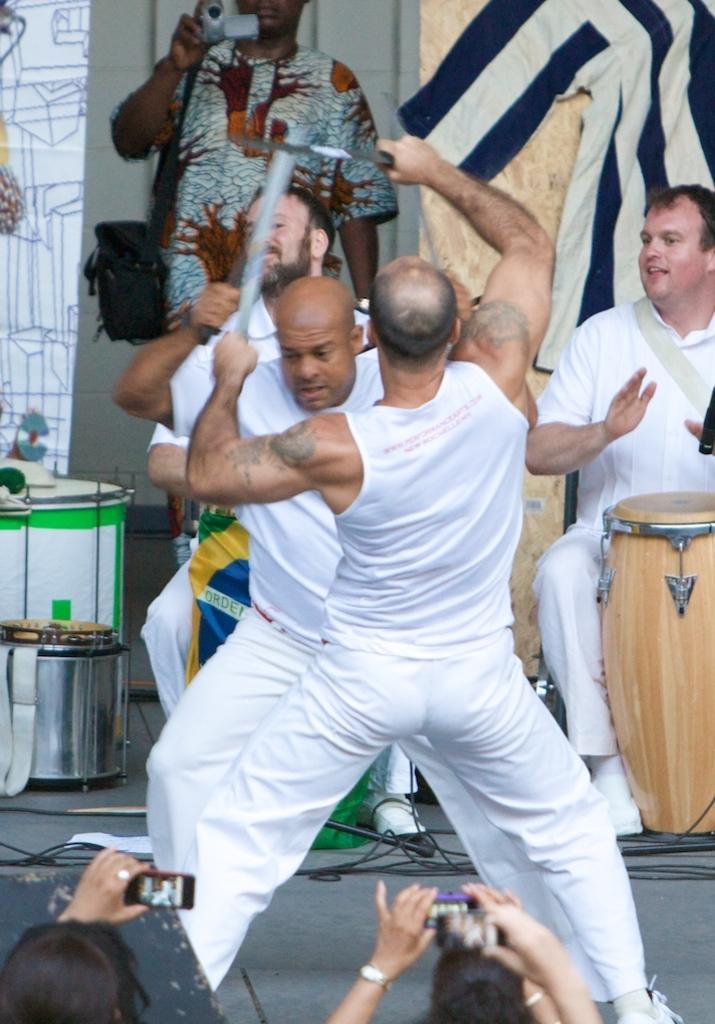Describe this image in one or two sentences. In the center of the image we can see two men wearing the white t shirts and standing on the floor and holding the swords. We can also see a man sitting in front of the drums. In the background there is a man wearing the bag and holding the camera and standing. There is also another man sitting. We can also see the drums, wall and also wires. At the bottom we can see the woman holding the mobile phones and capturing the photographs. 